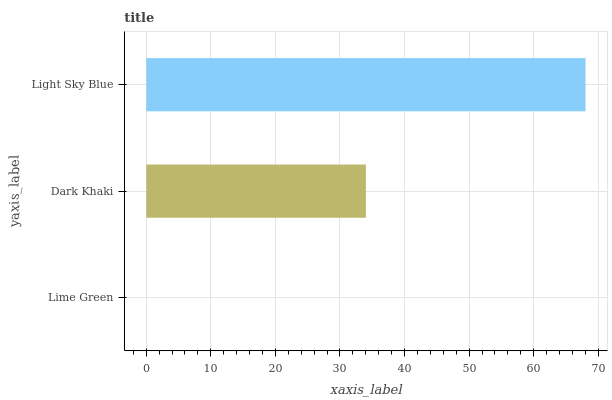Is Lime Green the minimum?
Answer yes or no. Yes. Is Light Sky Blue the maximum?
Answer yes or no. Yes. Is Dark Khaki the minimum?
Answer yes or no. No. Is Dark Khaki the maximum?
Answer yes or no. No. Is Dark Khaki greater than Lime Green?
Answer yes or no. Yes. Is Lime Green less than Dark Khaki?
Answer yes or no. Yes. Is Lime Green greater than Dark Khaki?
Answer yes or no. No. Is Dark Khaki less than Lime Green?
Answer yes or no. No. Is Dark Khaki the high median?
Answer yes or no. Yes. Is Dark Khaki the low median?
Answer yes or no. Yes. Is Light Sky Blue the high median?
Answer yes or no. No. Is Light Sky Blue the low median?
Answer yes or no. No. 